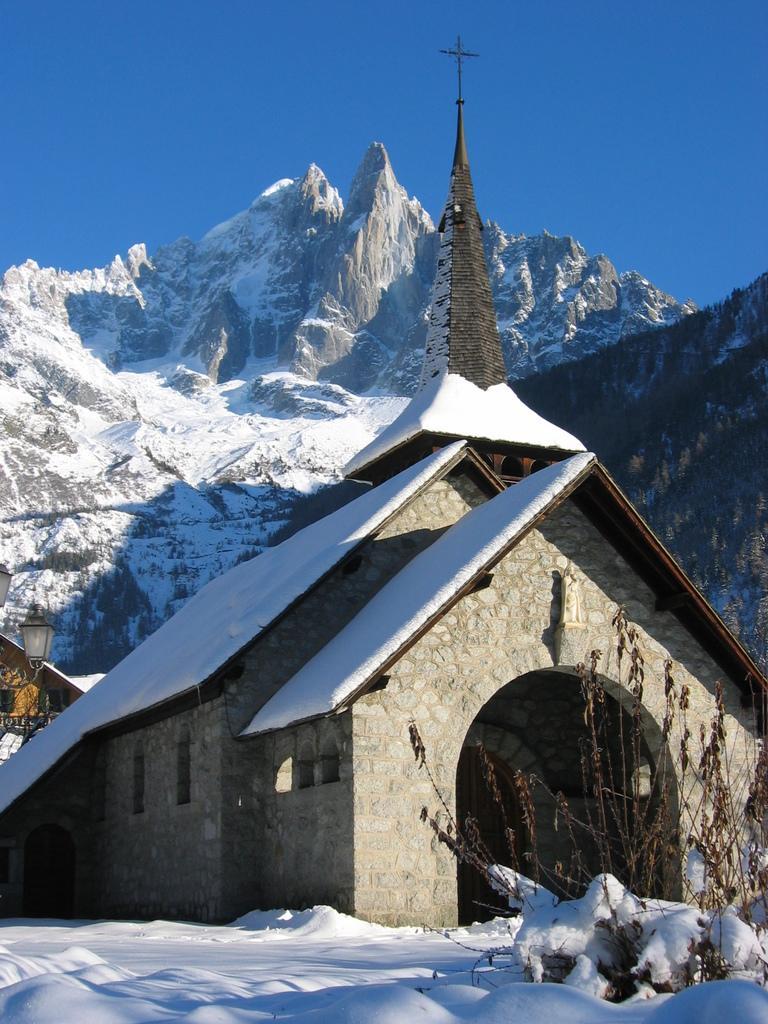Could you give a brief overview of what you see in this image? In this image I can see a plant, snow, houses, cross symbol, lights, trees, mountain and blue sky. 